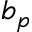<formula> <loc_0><loc_0><loc_500><loc_500>b _ { p }</formula> 